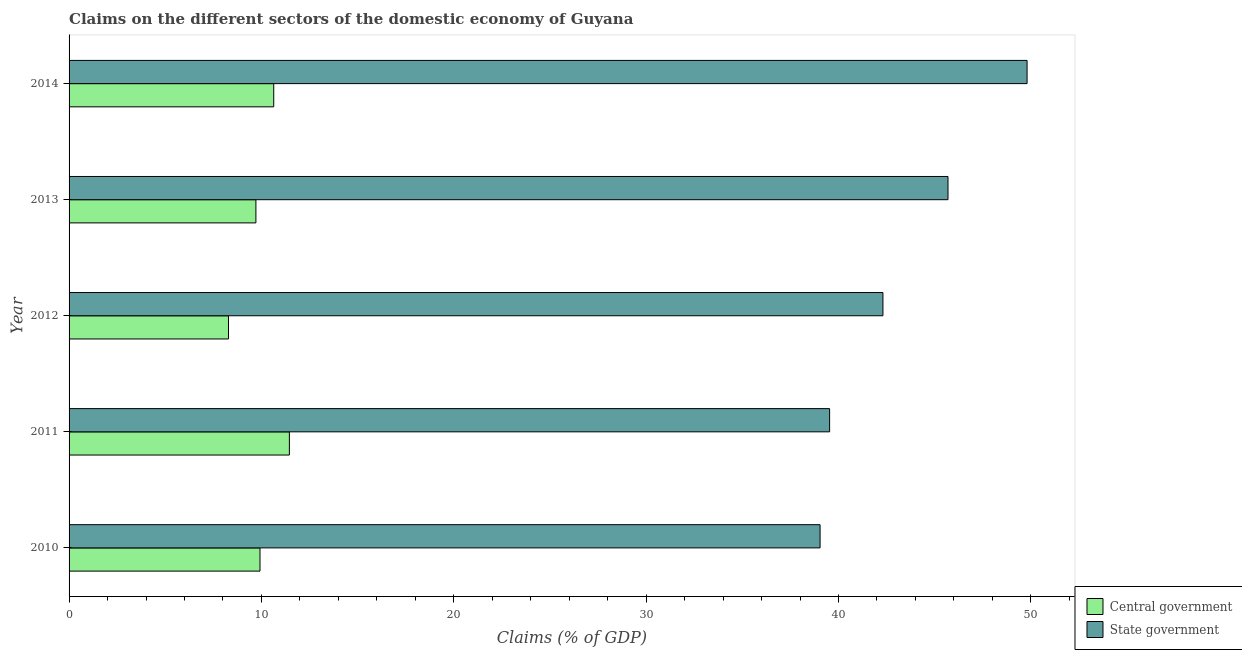How many different coloured bars are there?
Your answer should be compact. 2. How many bars are there on the 2nd tick from the bottom?
Give a very brief answer. 2. What is the label of the 5th group of bars from the top?
Provide a short and direct response. 2010. What is the claims on state government in 2014?
Provide a short and direct response. 49.8. Across all years, what is the maximum claims on central government?
Offer a terse response. 11.45. Across all years, what is the minimum claims on state government?
Your answer should be compact. 39.04. In which year was the claims on central government minimum?
Offer a terse response. 2012. What is the total claims on state government in the graph?
Keep it short and to the point. 216.38. What is the difference between the claims on central government in 2010 and that in 2013?
Your answer should be very brief. 0.21. What is the difference between the claims on state government in 2012 and the claims on central government in 2014?
Make the answer very short. 31.67. What is the average claims on central government per year?
Ensure brevity in your answer.  10. In the year 2012, what is the difference between the claims on central government and claims on state government?
Make the answer very short. -34.02. What is the ratio of the claims on central government in 2012 to that in 2014?
Your answer should be compact. 0.78. Is the claims on state government in 2011 less than that in 2013?
Your answer should be compact. Yes. What is the difference between the highest and the second highest claims on state government?
Give a very brief answer. 4.11. What is the difference between the highest and the lowest claims on central government?
Offer a very short reply. 3.17. What does the 1st bar from the top in 2011 represents?
Keep it short and to the point. State government. What does the 2nd bar from the bottom in 2012 represents?
Your response must be concise. State government. How many years are there in the graph?
Your answer should be very brief. 5. Are the values on the major ticks of X-axis written in scientific E-notation?
Offer a very short reply. No. How are the legend labels stacked?
Offer a terse response. Vertical. What is the title of the graph?
Your response must be concise. Claims on the different sectors of the domestic economy of Guyana. What is the label or title of the X-axis?
Ensure brevity in your answer.  Claims (% of GDP). What is the Claims (% of GDP) in Central government in 2010?
Your answer should be very brief. 9.93. What is the Claims (% of GDP) of State government in 2010?
Your response must be concise. 39.04. What is the Claims (% of GDP) in Central government in 2011?
Offer a very short reply. 11.45. What is the Claims (% of GDP) of State government in 2011?
Give a very brief answer. 39.54. What is the Claims (% of GDP) in Central government in 2012?
Provide a short and direct response. 8.29. What is the Claims (% of GDP) of State government in 2012?
Offer a very short reply. 42.31. What is the Claims (% of GDP) in Central government in 2013?
Keep it short and to the point. 9.71. What is the Claims (% of GDP) in State government in 2013?
Keep it short and to the point. 45.69. What is the Claims (% of GDP) of Central government in 2014?
Your answer should be very brief. 10.64. What is the Claims (% of GDP) of State government in 2014?
Offer a very short reply. 49.8. Across all years, what is the maximum Claims (% of GDP) in Central government?
Your response must be concise. 11.45. Across all years, what is the maximum Claims (% of GDP) in State government?
Your answer should be compact. 49.8. Across all years, what is the minimum Claims (% of GDP) of Central government?
Make the answer very short. 8.29. Across all years, what is the minimum Claims (% of GDP) in State government?
Offer a very short reply. 39.04. What is the total Claims (% of GDP) of Central government in the graph?
Make the answer very short. 50.02. What is the total Claims (% of GDP) of State government in the graph?
Offer a terse response. 216.38. What is the difference between the Claims (% of GDP) of Central government in 2010 and that in 2011?
Your response must be concise. -1.53. What is the difference between the Claims (% of GDP) in State government in 2010 and that in 2011?
Give a very brief answer. -0.5. What is the difference between the Claims (% of GDP) in Central government in 2010 and that in 2012?
Keep it short and to the point. 1.64. What is the difference between the Claims (% of GDP) of State government in 2010 and that in 2012?
Provide a short and direct response. -3.27. What is the difference between the Claims (% of GDP) in Central government in 2010 and that in 2013?
Your answer should be very brief. 0.21. What is the difference between the Claims (% of GDP) of State government in 2010 and that in 2013?
Your response must be concise. -6.65. What is the difference between the Claims (% of GDP) in Central government in 2010 and that in 2014?
Make the answer very short. -0.71. What is the difference between the Claims (% of GDP) of State government in 2010 and that in 2014?
Your answer should be very brief. -10.76. What is the difference between the Claims (% of GDP) in Central government in 2011 and that in 2012?
Your answer should be very brief. 3.17. What is the difference between the Claims (% of GDP) in State government in 2011 and that in 2012?
Your answer should be compact. -2.77. What is the difference between the Claims (% of GDP) in Central government in 2011 and that in 2013?
Make the answer very short. 1.74. What is the difference between the Claims (% of GDP) of State government in 2011 and that in 2013?
Your answer should be compact. -6.15. What is the difference between the Claims (% of GDP) in Central government in 2011 and that in 2014?
Make the answer very short. 0.81. What is the difference between the Claims (% of GDP) in State government in 2011 and that in 2014?
Make the answer very short. -10.27. What is the difference between the Claims (% of GDP) in Central government in 2012 and that in 2013?
Your response must be concise. -1.43. What is the difference between the Claims (% of GDP) of State government in 2012 and that in 2013?
Offer a very short reply. -3.38. What is the difference between the Claims (% of GDP) in Central government in 2012 and that in 2014?
Keep it short and to the point. -2.35. What is the difference between the Claims (% of GDP) of State government in 2012 and that in 2014?
Offer a very short reply. -7.49. What is the difference between the Claims (% of GDP) of Central government in 2013 and that in 2014?
Offer a very short reply. -0.93. What is the difference between the Claims (% of GDP) in State government in 2013 and that in 2014?
Provide a short and direct response. -4.11. What is the difference between the Claims (% of GDP) in Central government in 2010 and the Claims (% of GDP) in State government in 2011?
Your response must be concise. -29.61. What is the difference between the Claims (% of GDP) of Central government in 2010 and the Claims (% of GDP) of State government in 2012?
Your answer should be very brief. -32.38. What is the difference between the Claims (% of GDP) of Central government in 2010 and the Claims (% of GDP) of State government in 2013?
Provide a succinct answer. -35.77. What is the difference between the Claims (% of GDP) of Central government in 2010 and the Claims (% of GDP) of State government in 2014?
Ensure brevity in your answer.  -39.88. What is the difference between the Claims (% of GDP) of Central government in 2011 and the Claims (% of GDP) of State government in 2012?
Ensure brevity in your answer.  -30.86. What is the difference between the Claims (% of GDP) of Central government in 2011 and the Claims (% of GDP) of State government in 2013?
Give a very brief answer. -34.24. What is the difference between the Claims (% of GDP) in Central government in 2011 and the Claims (% of GDP) in State government in 2014?
Keep it short and to the point. -38.35. What is the difference between the Claims (% of GDP) in Central government in 2012 and the Claims (% of GDP) in State government in 2013?
Provide a succinct answer. -37.41. What is the difference between the Claims (% of GDP) in Central government in 2012 and the Claims (% of GDP) in State government in 2014?
Your answer should be very brief. -41.52. What is the difference between the Claims (% of GDP) in Central government in 2013 and the Claims (% of GDP) in State government in 2014?
Provide a succinct answer. -40.09. What is the average Claims (% of GDP) of Central government per year?
Offer a terse response. 10. What is the average Claims (% of GDP) of State government per year?
Provide a succinct answer. 43.28. In the year 2010, what is the difference between the Claims (% of GDP) of Central government and Claims (% of GDP) of State government?
Offer a terse response. -29.12. In the year 2011, what is the difference between the Claims (% of GDP) in Central government and Claims (% of GDP) in State government?
Make the answer very short. -28.08. In the year 2012, what is the difference between the Claims (% of GDP) in Central government and Claims (% of GDP) in State government?
Your answer should be compact. -34.02. In the year 2013, what is the difference between the Claims (% of GDP) of Central government and Claims (% of GDP) of State government?
Provide a short and direct response. -35.98. In the year 2014, what is the difference between the Claims (% of GDP) in Central government and Claims (% of GDP) in State government?
Provide a succinct answer. -39.16. What is the ratio of the Claims (% of GDP) of Central government in 2010 to that in 2011?
Ensure brevity in your answer.  0.87. What is the ratio of the Claims (% of GDP) in State government in 2010 to that in 2011?
Provide a succinct answer. 0.99. What is the ratio of the Claims (% of GDP) in Central government in 2010 to that in 2012?
Offer a terse response. 1.2. What is the ratio of the Claims (% of GDP) of State government in 2010 to that in 2012?
Offer a terse response. 0.92. What is the ratio of the Claims (% of GDP) in Central government in 2010 to that in 2013?
Your answer should be very brief. 1.02. What is the ratio of the Claims (% of GDP) in State government in 2010 to that in 2013?
Provide a succinct answer. 0.85. What is the ratio of the Claims (% of GDP) in Central government in 2010 to that in 2014?
Provide a short and direct response. 0.93. What is the ratio of the Claims (% of GDP) of State government in 2010 to that in 2014?
Provide a short and direct response. 0.78. What is the ratio of the Claims (% of GDP) of Central government in 2011 to that in 2012?
Provide a short and direct response. 1.38. What is the ratio of the Claims (% of GDP) of State government in 2011 to that in 2012?
Provide a succinct answer. 0.93. What is the ratio of the Claims (% of GDP) of Central government in 2011 to that in 2013?
Make the answer very short. 1.18. What is the ratio of the Claims (% of GDP) of State government in 2011 to that in 2013?
Make the answer very short. 0.87. What is the ratio of the Claims (% of GDP) of Central government in 2011 to that in 2014?
Offer a very short reply. 1.08. What is the ratio of the Claims (% of GDP) of State government in 2011 to that in 2014?
Your response must be concise. 0.79. What is the ratio of the Claims (% of GDP) in Central government in 2012 to that in 2013?
Offer a terse response. 0.85. What is the ratio of the Claims (% of GDP) in State government in 2012 to that in 2013?
Your answer should be very brief. 0.93. What is the ratio of the Claims (% of GDP) of Central government in 2012 to that in 2014?
Your answer should be very brief. 0.78. What is the ratio of the Claims (% of GDP) of State government in 2012 to that in 2014?
Ensure brevity in your answer.  0.85. What is the ratio of the Claims (% of GDP) of Central government in 2013 to that in 2014?
Give a very brief answer. 0.91. What is the ratio of the Claims (% of GDP) in State government in 2013 to that in 2014?
Your answer should be compact. 0.92. What is the difference between the highest and the second highest Claims (% of GDP) in Central government?
Ensure brevity in your answer.  0.81. What is the difference between the highest and the second highest Claims (% of GDP) in State government?
Ensure brevity in your answer.  4.11. What is the difference between the highest and the lowest Claims (% of GDP) of Central government?
Offer a terse response. 3.17. What is the difference between the highest and the lowest Claims (% of GDP) in State government?
Provide a short and direct response. 10.76. 